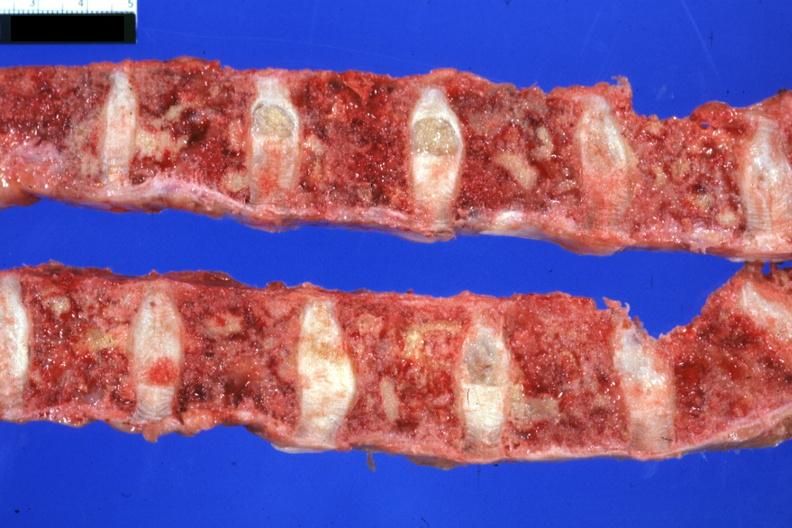what is present?
Answer the question using a single word or phrase. Joints 